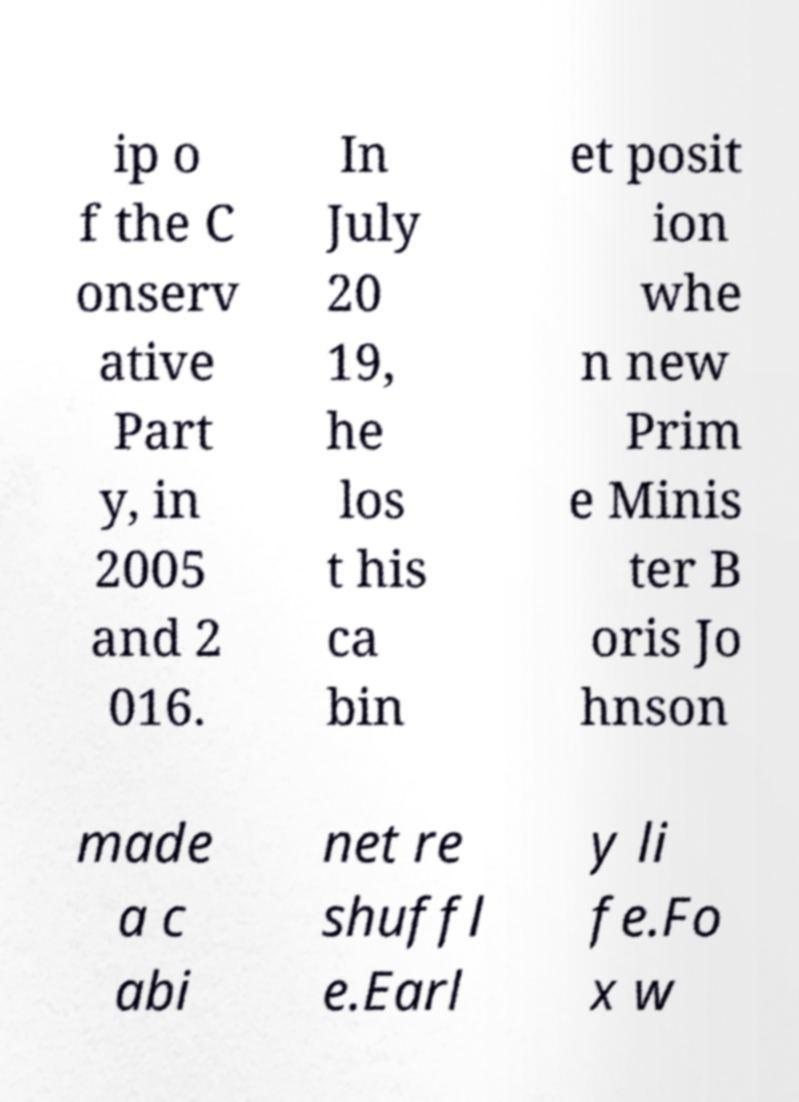Please identify and transcribe the text found in this image. ip o f the C onserv ative Part y, in 2005 and 2 016. In July 20 19, he los t his ca bin et posit ion whe n new Prim e Minis ter B oris Jo hnson made a c abi net re shuffl e.Earl y li fe.Fo x w 